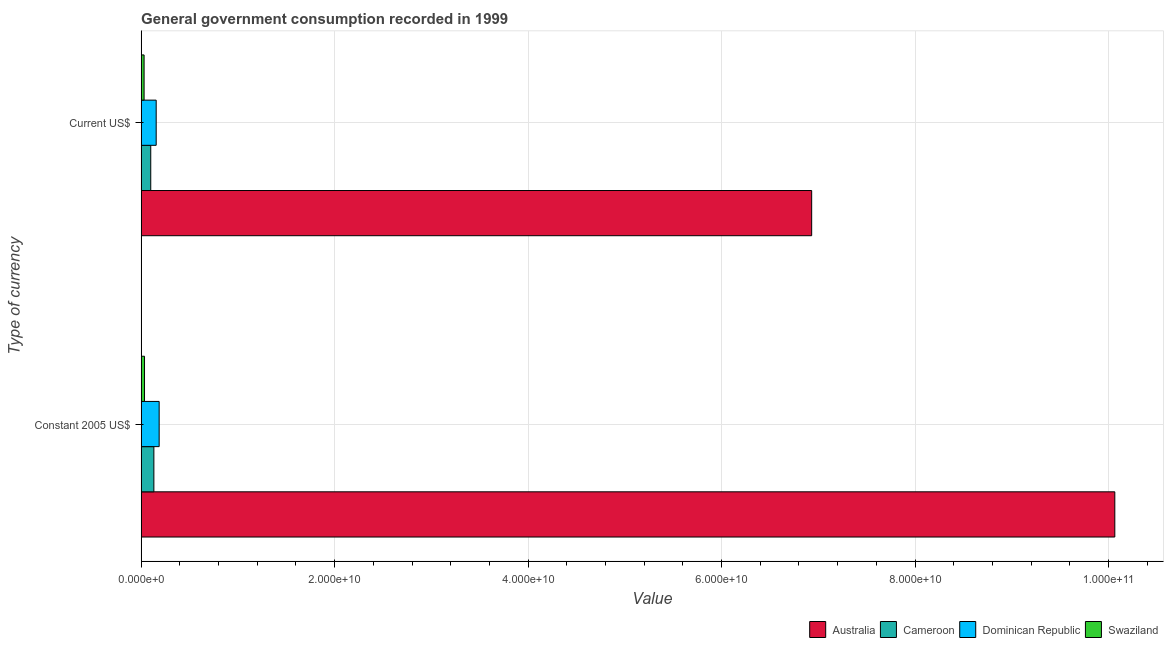How many groups of bars are there?
Your answer should be very brief. 2. How many bars are there on the 2nd tick from the top?
Your answer should be compact. 4. What is the label of the 1st group of bars from the top?
Your answer should be very brief. Current US$. What is the value consumed in constant 2005 us$ in Australia?
Make the answer very short. 1.01e+11. Across all countries, what is the maximum value consumed in constant 2005 us$?
Offer a terse response. 1.01e+11. Across all countries, what is the minimum value consumed in constant 2005 us$?
Your answer should be compact. 3.47e+08. In which country was the value consumed in current us$ maximum?
Your answer should be very brief. Australia. In which country was the value consumed in current us$ minimum?
Your answer should be very brief. Swaziland. What is the total value consumed in current us$ in the graph?
Ensure brevity in your answer.  7.22e+1. What is the difference between the value consumed in current us$ in Cameroon and that in Dominican Republic?
Offer a very short reply. -5.62e+08. What is the difference between the value consumed in current us$ in Australia and the value consumed in constant 2005 us$ in Swaziland?
Your answer should be compact. 6.90e+1. What is the average value consumed in constant 2005 us$ per country?
Provide a succinct answer. 2.60e+1. What is the difference between the value consumed in constant 2005 us$ and value consumed in current us$ in Swaziland?
Offer a very short reply. 4.23e+07. What is the ratio of the value consumed in current us$ in Australia to that in Dominican Republic?
Ensure brevity in your answer.  44.6. In how many countries, is the value consumed in constant 2005 us$ greater than the average value consumed in constant 2005 us$ taken over all countries?
Offer a terse response. 1. What does the 1st bar from the top in Current US$ represents?
Your answer should be compact. Swaziland. What does the 1st bar from the bottom in Current US$ represents?
Ensure brevity in your answer.  Australia. How many bars are there?
Provide a short and direct response. 8. How many countries are there in the graph?
Ensure brevity in your answer.  4. What is the difference between two consecutive major ticks on the X-axis?
Keep it short and to the point. 2.00e+1. Are the values on the major ticks of X-axis written in scientific E-notation?
Offer a very short reply. Yes. Does the graph contain any zero values?
Give a very brief answer. No. Does the graph contain grids?
Keep it short and to the point. Yes. Where does the legend appear in the graph?
Make the answer very short. Bottom right. What is the title of the graph?
Offer a very short reply. General government consumption recorded in 1999. Does "South Africa" appear as one of the legend labels in the graph?
Make the answer very short. No. What is the label or title of the X-axis?
Your response must be concise. Value. What is the label or title of the Y-axis?
Your response must be concise. Type of currency. What is the Value of Australia in Constant 2005 US$?
Your response must be concise. 1.01e+11. What is the Value in Cameroon in Constant 2005 US$?
Your answer should be very brief. 1.32e+09. What is the Value of Dominican Republic in Constant 2005 US$?
Your answer should be compact. 1.86e+09. What is the Value of Swaziland in Constant 2005 US$?
Offer a terse response. 3.47e+08. What is the Value of Australia in Current US$?
Your response must be concise. 6.93e+1. What is the Value of Cameroon in Current US$?
Make the answer very short. 9.92e+08. What is the Value of Dominican Republic in Current US$?
Provide a succinct answer. 1.55e+09. What is the Value in Swaziland in Current US$?
Ensure brevity in your answer.  3.05e+08. Across all Type of currency, what is the maximum Value of Australia?
Provide a short and direct response. 1.01e+11. Across all Type of currency, what is the maximum Value in Cameroon?
Ensure brevity in your answer.  1.32e+09. Across all Type of currency, what is the maximum Value in Dominican Republic?
Your response must be concise. 1.86e+09. Across all Type of currency, what is the maximum Value of Swaziland?
Make the answer very short. 3.47e+08. Across all Type of currency, what is the minimum Value of Australia?
Your response must be concise. 6.93e+1. Across all Type of currency, what is the minimum Value in Cameroon?
Your response must be concise. 9.92e+08. Across all Type of currency, what is the minimum Value of Dominican Republic?
Your answer should be very brief. 1.55e+09. Across all Type of currency, what is the minimum Value of Swaziland?
Make the answer very short. 3.05e+08. What is the total Value of Australia in the graph?
Make the answer very short. 1.70e+11. What is the total Value of Cameroon in the graph?
Ensure brevity in your answer.  2.31e+09. What is the total Value of Dominican Republic in the graph?
Your answer should be very brief. 3.42e+09. What is the total Value in Swaziland in the graph?
Offer a terse response. 6.53e+08. What is the difference between the Value in Australia in Constant 2005 US$ and that in Current US$?
Ensure brevity in your answer.  3.13e+1. What is the difference between the Value of Cameroon in Constant 2005 US$ and that in Current US$?
Provide a short and direct response. 3.23e+08. What is the difference between the Value in Dominican Republic in Constant 2005 US$ and that in Current US$?
Your answer should be very brief. 3.08e+08. What is the difference between the Value in Swaziland in Constant 2005 US$ and that in Current US$?
Make the answer very short. 4.23e+07. What is the difference between the Value of Australia in Constant 2005 US$ and the Value of Cameroon in Current US$?
Give a very brief answer. 9.97e+1. What is the difference between the Value in Australia in Constant 2005 US$ and the Value in Dominican Republic in Current US$?
Your answer should be compact. 9.91e+1. What is the difference between the Value in Australia in Constant 2005 US$ and the Value in Swaziland in Current US$?
Provide a short and direct response. 1.00e+11. What is the difference between the Value of Cameroon in Constant 2005 US$ and the Value of Dominican Republic in Current US$?
Your answer should be compact. -2.39e+08. What is the difference between the Value in Cameroon in Constant 2005 US$ and the Value in Swaziland in Current US$?
Your answer should be compact. 1.01e+09. What is the difference between the Value of Dominican Republic in Constant 2005 US$ and the Value of Swaziland in Current US$?
Your answer should be compact. 1.56e+09. What is the average Value in Australia per Type of currency?
Keep it short and to the point. 8.50e+1. What is the average Value in Cameroon per Type of currency?
Offer a terse response. 1.15e+09. What is the average Value in Dominican Republic per Type of currency?
Ensure brevity in your answer.  1.71e+09. What is the average Value of Swaziland per Type of currency?
Offer a very short reply. 3.26e+08. What is the difference between the Value in Australia and Value in Cameroon in Constant 2005 US$?
Offer a terse response. 9.93e+1. What is the difference between the Value in Australia and Value in Dominican Republic in Constant 2005 US$?
Offer a terse response. 9.88e+1. What is the difference between the Value of Australia and Value of Swaziland in Constant 2005 US$?
Ensure brevity in your answer.  1.00e+11. What is the difference between the Value of Cameroon and Value of Dominican Republic in Constant 2005 US$?
Offer a very short reply. -5.47e+08. What is the difference between the Value of Cameroon and Value of Swaziland in Constant 2005 US$?
Offer a terse response. 9.68e+08. What is the difference between the Value in Dominican Republic and Value in Swaziland in Constant 2005 US$?
Your answer should be very brief. 1.51e+09. What is the difference between the Value in Australia and Value in Cameroon in Current US$?
Provide a short and direct response. 6.83e+1. What is the difference between the Value in Australia and Value in Dominican Republic in Current US$?
Ensure brevity in your answer.  6.78e+1. What is the difference between the Value in Australia and Value in Swaziland in Current US$?
Keep it short and to the point. 6.90e+1. What is the difference between the Value of Cameroon and Value of Dominican Republic in Current US$?
Ensure brevity in your answer.  -5.62e+08. What is the difference between the Value of Cameroon and Value of Swaziland in Current US$?
Keep it short and to the point. 6.87e+08. What is the difference between the Value of Dominican Republic and Value of Swaziland in Current US$?
Give a very brief answer. 1.25e+09. What is the ratio of the Value of Australia in Constant 2005 US$ to that in Current US$?
Give a very brief answer. 1.45. What is the ratio of the Value in Cameroon in Constant 2005 US$ to that in Current US$?
Your answer should be compact. 1.33. What is the ratio of the Value in Dominican Republic in Constant 2005 US$ to that in Current US$?
Ensure brevity in your answer.  1.2. What is the ratio of the Value in Swaziland in Constant 2005 US$ to that in Current US$?
Keep it short and to the point. 1.14. What is the difference between the highest and the second highest Value in Australia?
Provide a succinct answer. 3.13e+1. What is the difference between the highest and the second highest Value of Cameroon?
Keep it short and to the point. 3.23e+08. What is the difference between the highest and the second highest Value in Dominican Republic?
Make the answer very short. 3.08e+08. What is the difference between the highest and the second highest Value of Swaziland?
Ensure brevity in your answer.  4.23e+07. What is the difference between the highest and the lowest Value in Australia?
Give a very brief answer. 3.13e+1. What is the difference between the highest and the lowest Value in Cameroon?
Keep it short and to the point. 3.23e+08. What is the difference between the highest and the lowest Value in Dominican Republic?
Give a very brief answer. 3.08e+08. What is the difference between the highest and the lowest Value of Swaziland?
Offer a very short reply. 4.23e+07. 